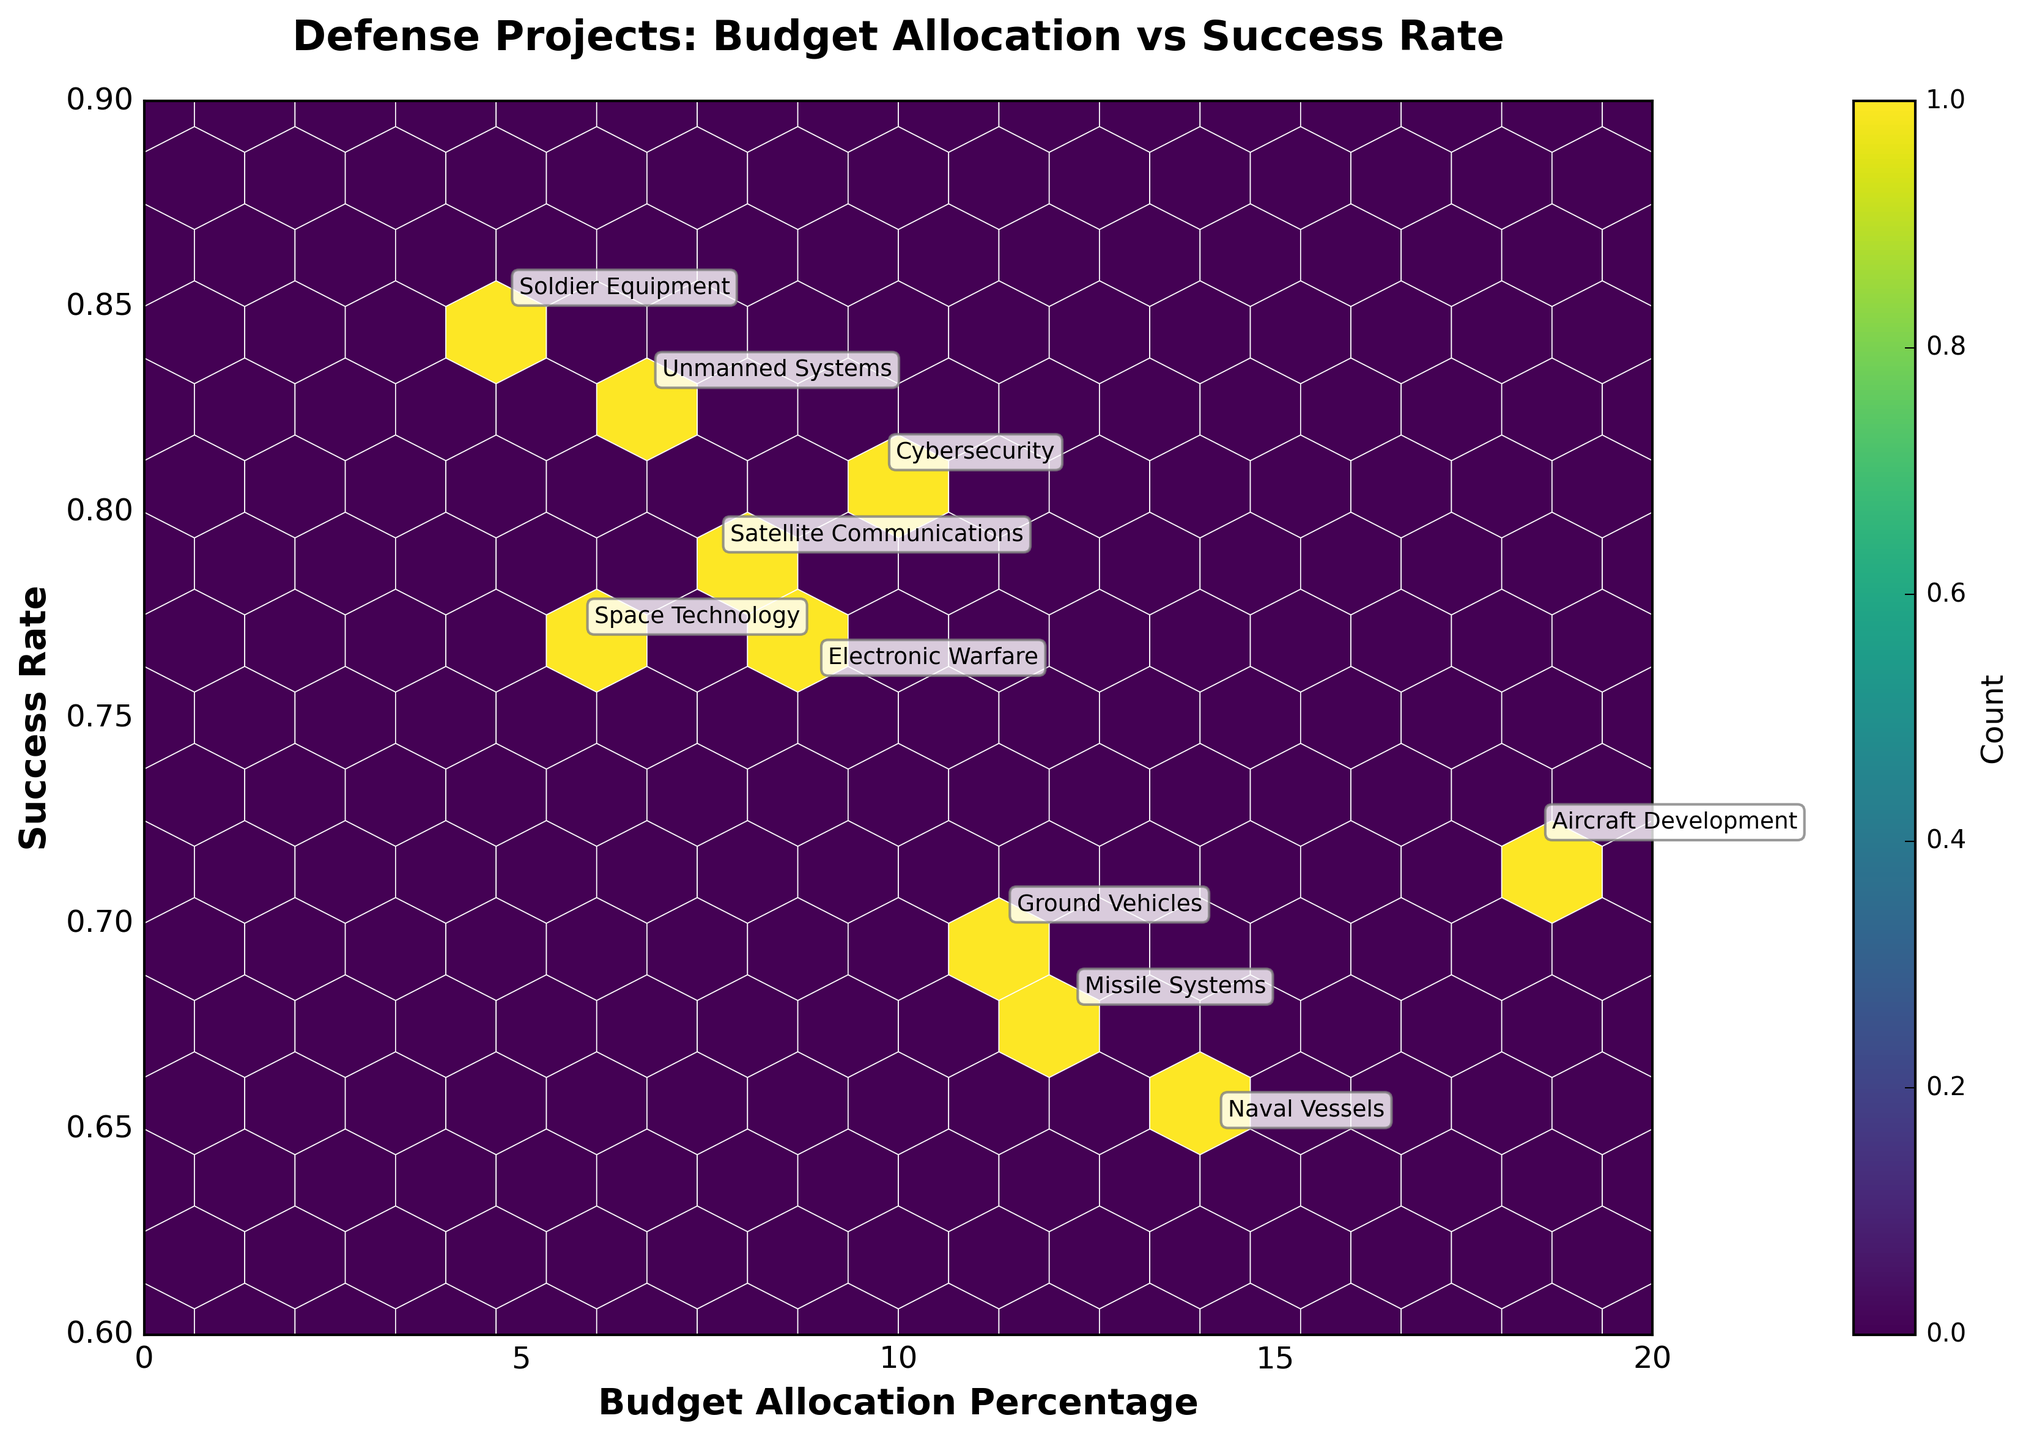What's the title of the figure? The title of the figure is at the top, written clearly in bold and larger font size compared to other text elements. It directly describes the purpose or the main theme of the visualization.
Answer: Defense Projects: Budget Allocation vs Success Rate What do the x and y axes represent? The x-axis represents the "Budget Allocation Percentage," indicating how much of the budget is allocated to each project category. The y-axis represents the "Success Rate" of these projects.
Answer: Budget Allocation Percentage and Success Rate Which project category has the highest success rate? By looking at the plot and identifying the point on the y-axis that is the highest, you'll see it corresponds to the "Soldier Equipment" project category, whose success rate is at 0.85.
Answer: Soldier Equipment Between Aircraft Development and Missile Systems, which project category has the higher success rate? Comparing the y-values of the two annotated points representing these categories, Aircraft Development has a success rate of 0.72, while Missile Systems has a success rate of 0.68. Thus, Aircraft Development has the higher success rate.
Answer: Aircraft Development How many project categories have a success rate above 0.80? Observing the points positioned above the 0.80 mark on the y-axis, you will find that three project categories (Cybersecurity, Unmanned Systems, and Soldier Equipment) have success rates above 0.80.
Answer: Three Which project category has the smallest budget allocation percentage, and what is its success rate? Identify the point furthest to the left on the x-axis; it represents "Space Technology." Its budget allocation percentage is 5.8%, and it has a success rate of 0.77.
Answer: Space Technology with a success rate of 0.77 How does the success rate of Naval Vessels compare to that of Ground Vehicles? The y-values corresponding to "Naval Vessels" is 0.65, and "Ground Vehicles" is 0.70. Ground Vehicles has a higher success rate than Naval Vessels.
Answer: Ground Vehicles has a higher success rate What is the average success rate of the project categories with budget allocation percentages below 10%? The project categories below 10% budget are Cybersecurity (0.81), Satellite Communications (0.79), Electronic Warfare (0.76), Unmanned Systems (0.83), Space Technology (0.77), and Soldier Equipment (0.85). Summing these success rates: 0.81 + 0.79 + 0.76 + 0.83 + 0.77 + 0.85 =  4.81. Now, dividing by the 6 categories: 4.81 / 6 = ~0.80.
Answer: ~0.80 What is the range of budget allocation percentages among the project categories? Find the minimum and maximum values for budget allocation percentages. The minimum is for "Space Technology" (5.8%) and the maximum is for "Aircraft Development" (18.5%). The range is 18.5% - 5.8% = 12.7%.
Answer: 12.7% 